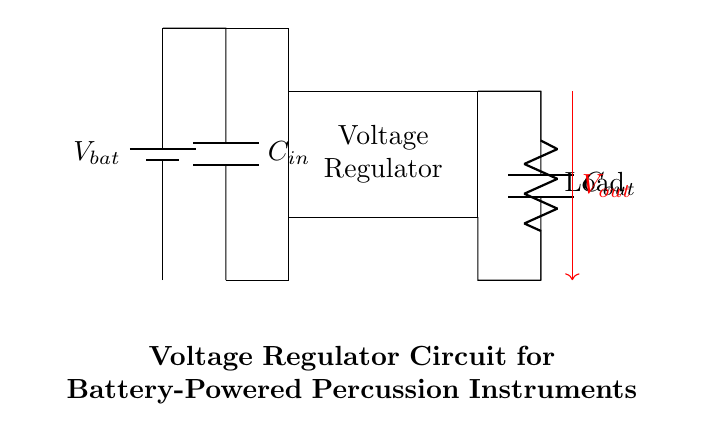What is the main component used to regulate voltage? The main component responsible for voltage regulation in this circuit is the voltage regulator, which is represented by the rectangular block in the diagram. Its purpose is to maintain a constant output voltage despite variations in input voltage or load conditions.
Answer: Voltage regulator What is the function of the capacitors in this circuit? The capacitors, labeled as C_in and C_out, serve to smooth the voltage and filter out noise. The input capacitor C_in stabilizes the input voltage to the regulator, while the output capacitor C_out ensures a steady output voltage by reducing voltage fluctuations caused by the load.
Answer: Smoothing and filtering What is the voltage of the battery in this circuit? The battery voltage (V_bat) is designated in the diagram, but the specific voltage value is not provided. However, it typically supplies power to the voltage regulator to ensure that the output voltage (V_out) remains stable under varying loads.
Answer: V_bat How many capacitors are present in this circuit? There are two capacitors in the circuit diagram, one at the input (C_in) and one at the output (C_out). Both capacitors play crucial roles in stabilizing the voltage for the circuit's operation.
Answer: Two What is the load represented in this circuit? The load in the circuit is represented by a resistor, which indicates it is the component that consumes power from the regulated output voltage. The resistor symbolizes the device that will use the regulated voltage for its operation.
Answer: Resistor How does the voltage regulator affect the output voltage? The voltage regulator maintains a constant output voltage (V_out) regardless of variations in the input voltage (V_bat) or the changes in load. This is achieved through feedback mechanisms within the regulator that adjust the output accordingly to ensure stability.
Answer: Maintains stability What are the two types of capacitors used in this circuit? The two types of capacitors are the input capacitor (C_in) and the output capacitor (C_out). C_in helps in smoothing the incoming power supply, while C_out works to stabilize the output voltage by filtering fluctuations that occur when the load changes.
Answer: Input and output 